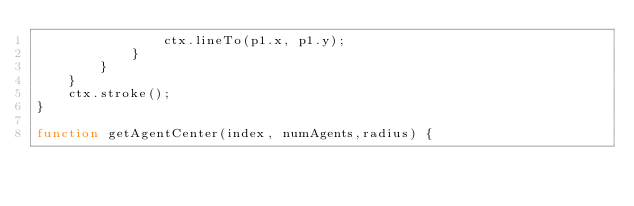Convert code to text. <code><loc_0><loc_0><loc_500><loc_500><_JavaScript_>				ctx.lineTo(p1.x, p1.y);
			}
		}
	}
	ctx.stroke();
}

function getAgentCenter(index, numAgents,radius) {</code> 